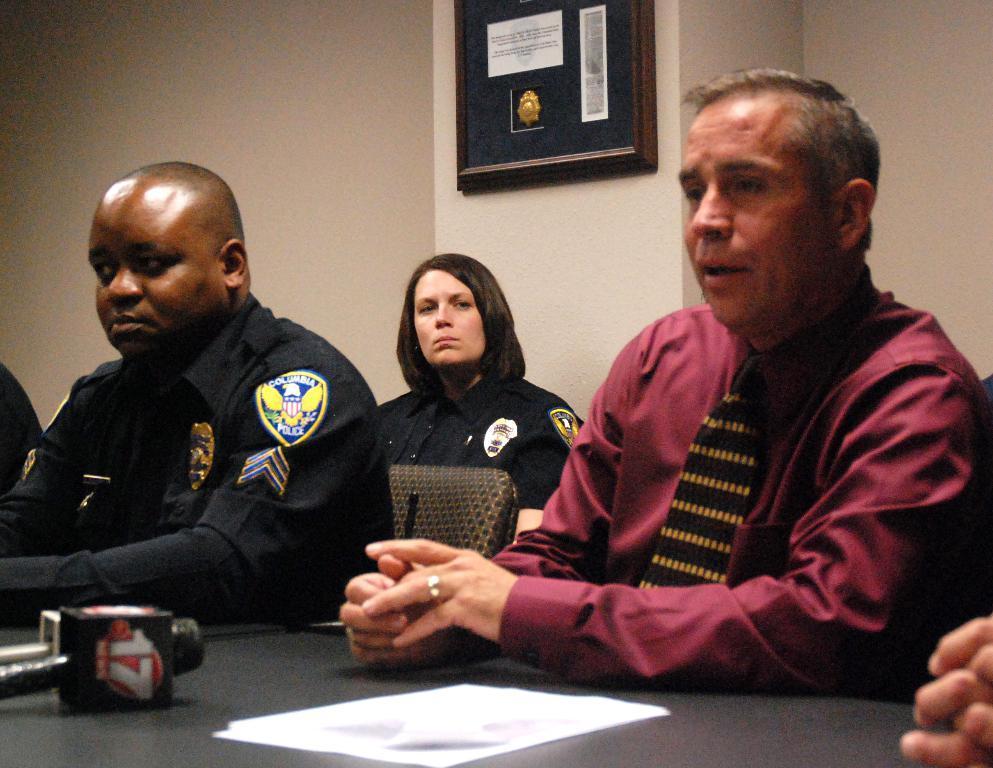In one or two sentences, can you explain what this image depicts? In the picture we can see a two men are sitting on the chairs, one man is in police uniform and one man is in shirt and a tie to it and behind them, we can see a woman sitting in a police uniform and on the desk, we can see some papers and microphone of a channel and in the background we can see a wall with a photo frame. 